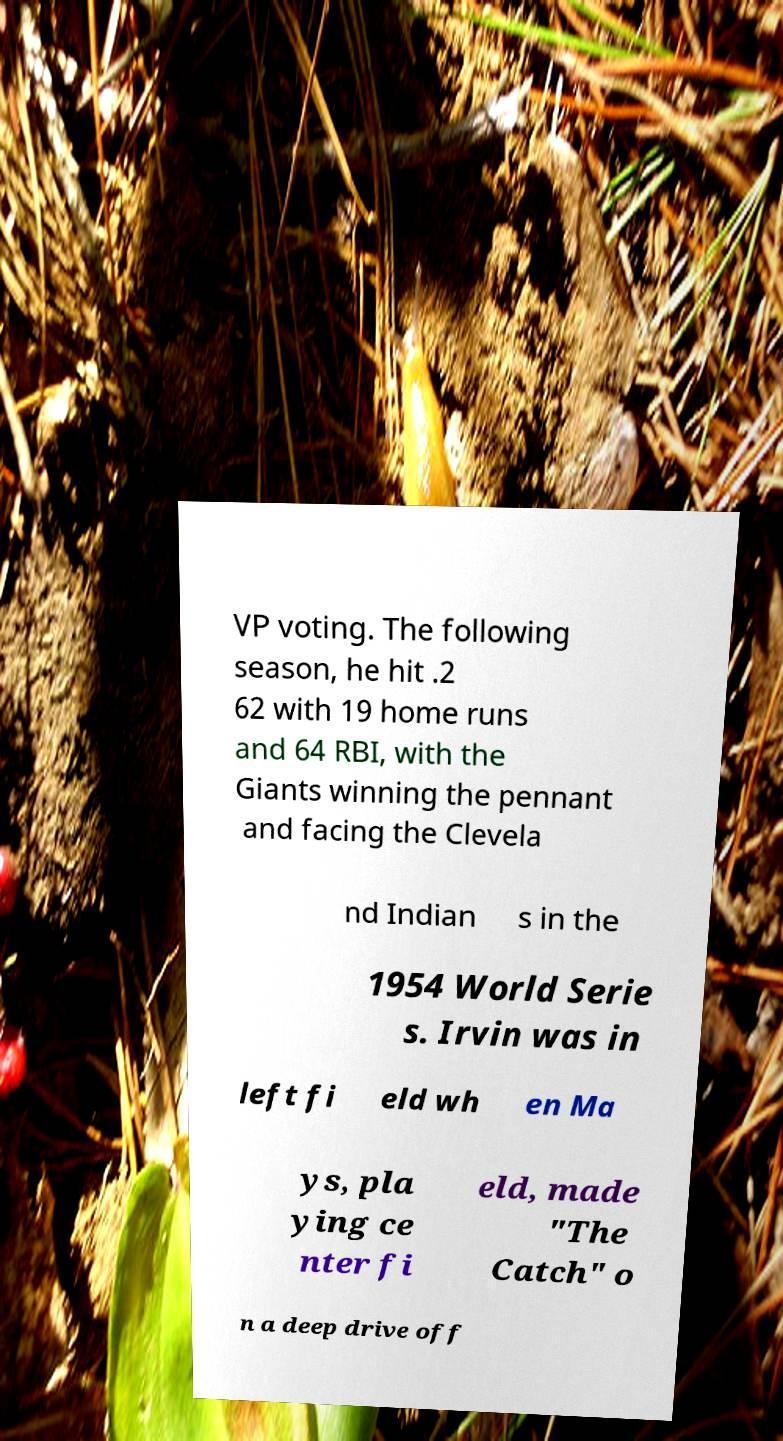I need the written content from this picture converted into text. Can you do that? VP voting. The following season, he hit .2 62 with 19 home runs and 64 RBI, with the Giants winning the pennant and facing the Clevela nd Indian s in the 1954 World Serie s. Irvin was in left fi eld wh en Ma ys, pla ying ce nter fi eld, made "The Catch" o n a deep drive off 